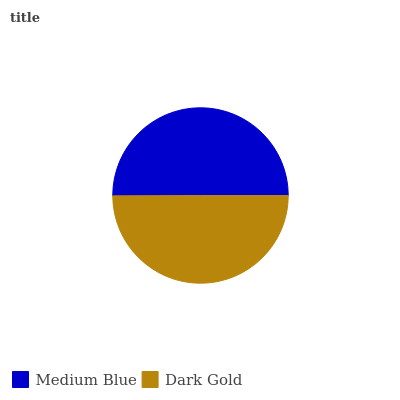Is Dark Gold the minimum?
Answer yes or no. Yes. Is Medium Blue the maximum?
Answer yes or no. Yes. Is Dark Gold the maximum?
Answer yes or no. No. Is Medium Blue greater than Dark Gold?
Answer yes or no. Yes. Is Dark Gold less than Medium Blue?
Answer yes or no. Yes. Is Dark Gold greater than Medium Blue?
Answer yes or no. No. Is Medium Blue less than Dark Gold?
Answer yes or no. No. Is Medium Blue the high median?
Answer yes or no. Yes. Is Dark Gold the low median?
Answer yes or no. Yes. Is Dark Gold the high median?
Answer yes or no. No. Is Medium Blue the low median?
Answer yes or no. No. 